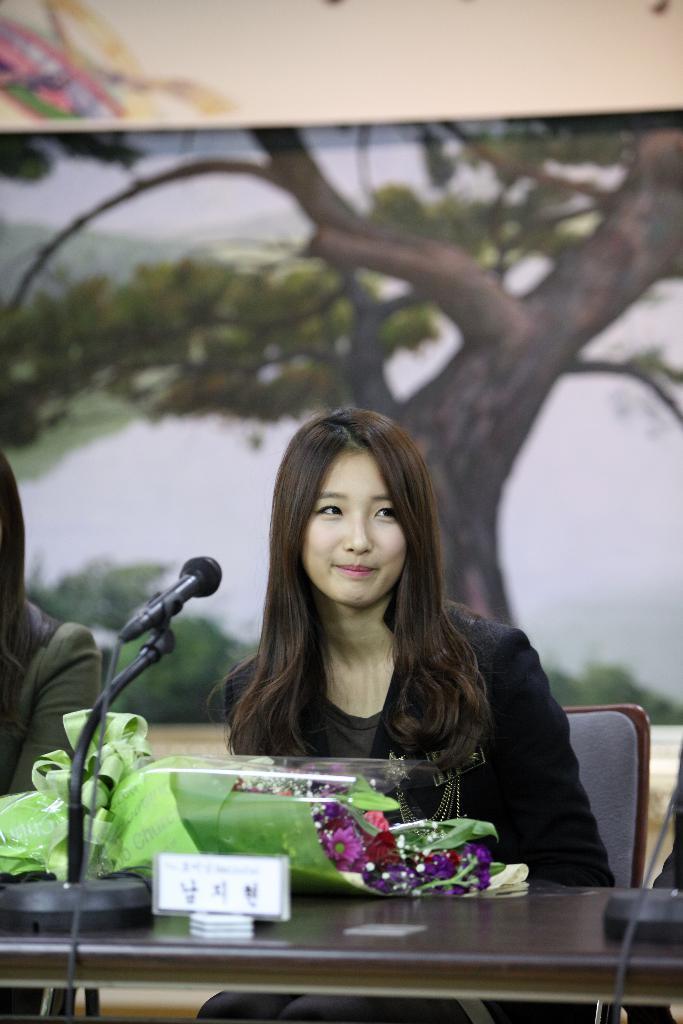Could you give a brief overview of what you see in this image? In this image there is a woman sitting on a chair and there is a table on which mic, bouquet with flowers is present on it. At the background there is a poster with a tree on it. 